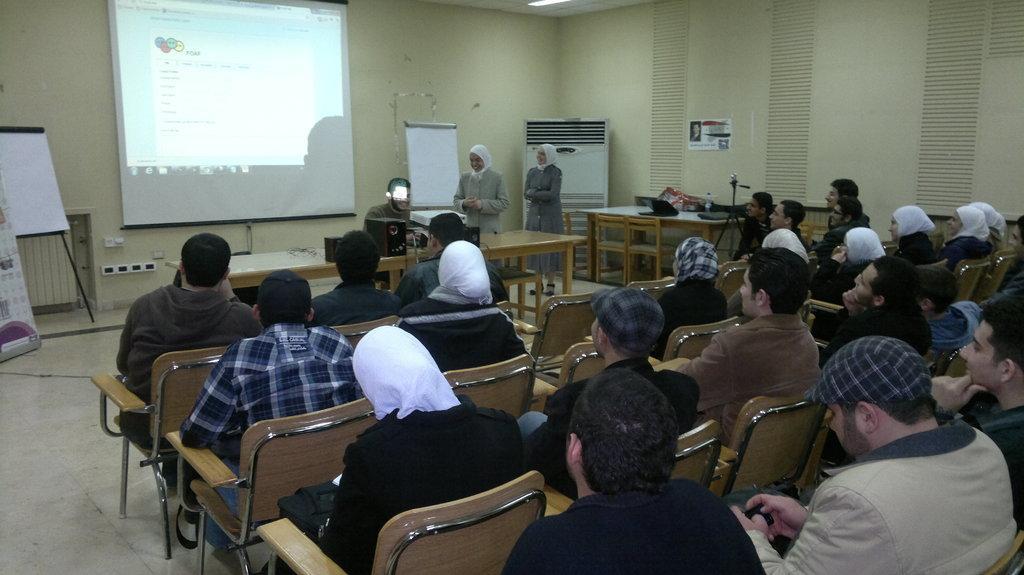Describe this image in one or two sentences. In this picture we can see some persons are sitting on the chairs. This is table. On the table there are some electronic devices. Here we can see two persons standing on the floor. On the background there is a screen and this is wall. Here we can see a board. 